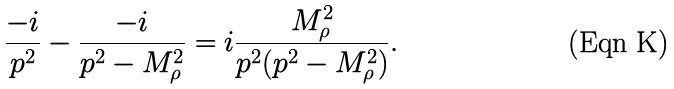Convert formula to latex. <formula><loc_0><loc_0><loc_500><loc_500>\frac { - i } { p ^ { 2 } } - \frac { - i } { p ^ { 2 } - M _ { \rho } ^ { 2 } } = i \frac { M _ { \rho } ^ { 2 } } { p ^ { 2 } ( p ^ { 2 } - M _ { \rho } ^ { 2 } ) } .</formula> 